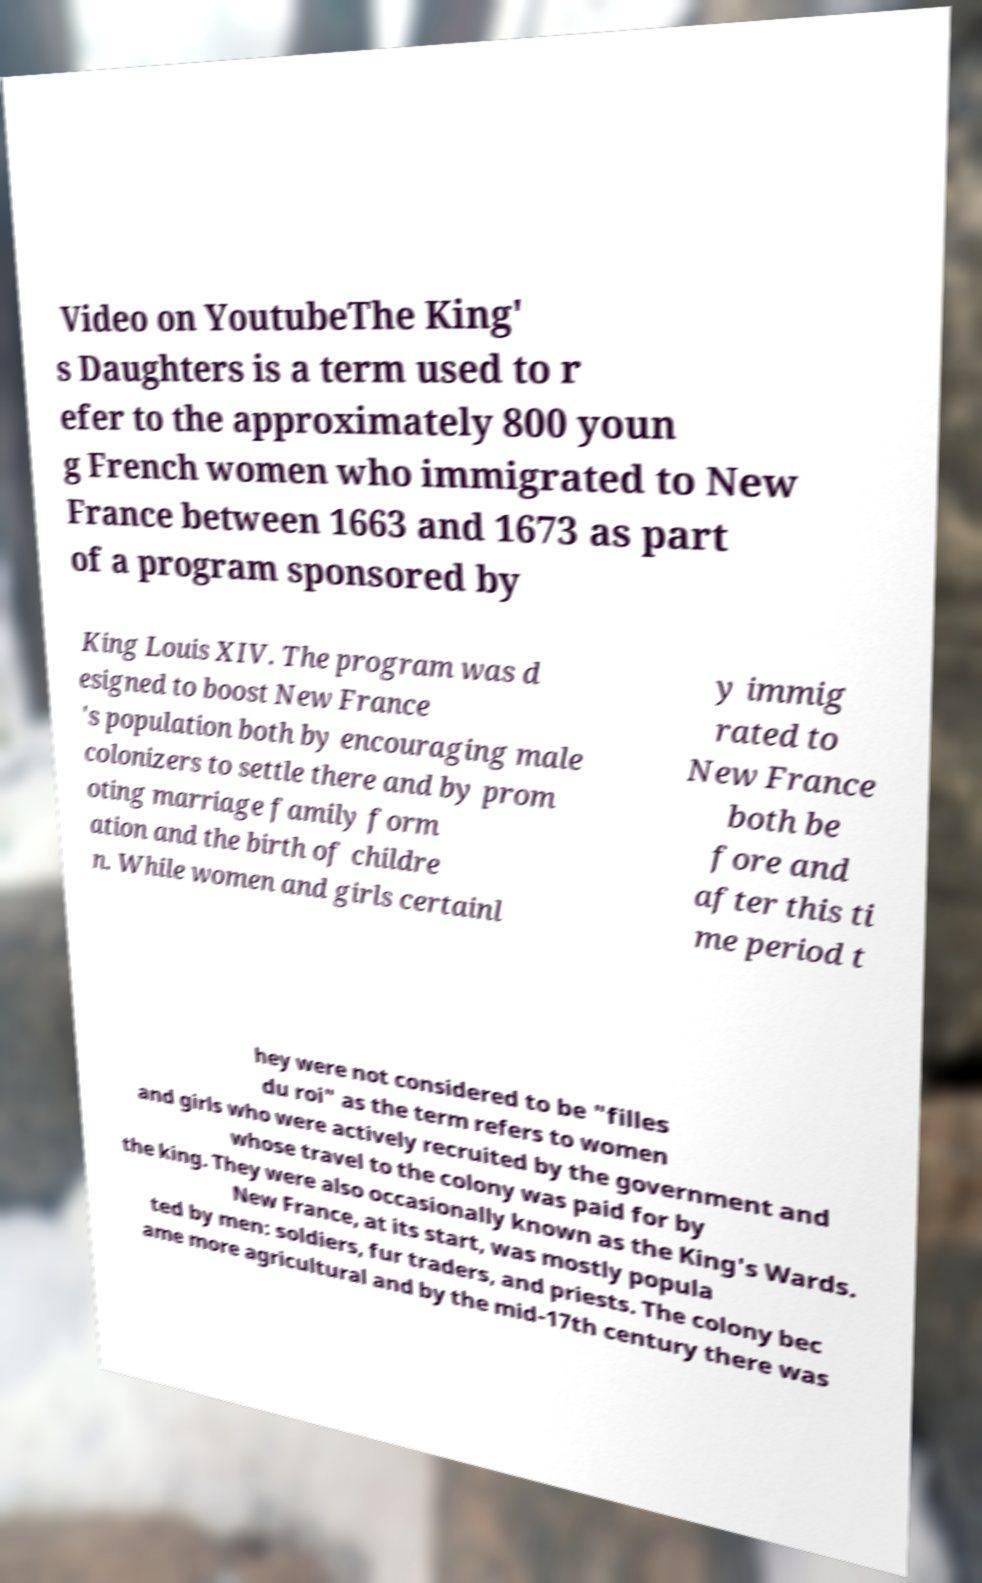Can you read and provide the text displayed in the image?This photo seems to have some interesting text. Can you extract and type it out for me? Video on YoutubeThe King' s Daughters is a term used to r efer to the approximately 800 youn g French women who immigrated to New France between 1663 and 1673 as part of a program sponsored by King Louis XIV. The program was d esigned to boost New France 's population both by encouraging male colonizers to settle there and by prom oting marriage family form ation and the birth of childre n. While women and girls certainl y immig rated to New France both be fore and after this ti me period t hey were not considered to be "filles du roi" as the term refers to women and girls who were actively recruited by the government and whose travel to the colony was paid for by the king. They were also occasionally known as the King's Wards. New France, at its start, was mostly popula ted by men: soldiers, fur traders, and priests. The colony bec ame more agricultural and by the mid-17th century there was 